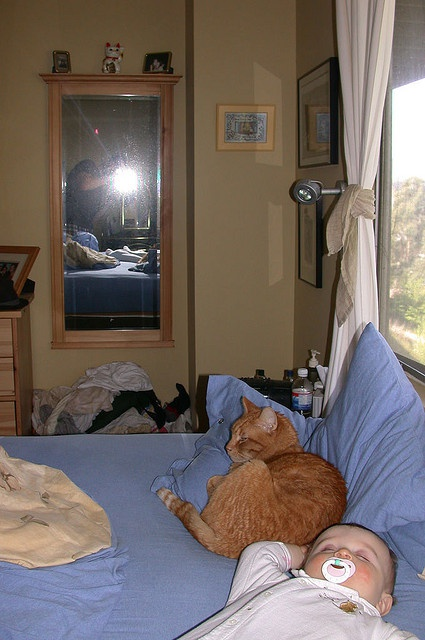Describe the objects in this image and their specific colors. I can see bed in maroon and gray tones, people in maroon, lightgray, darkgray, lightpink, and gray tones, cat in maroon, brown, and gray tones, people in maroon, gray, black, and darkgray tones, and bottle in maroon, black, gray, darkgray, and navy tones in this image. 